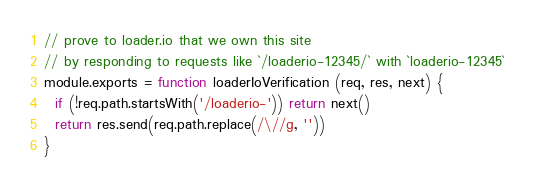<code> <loc_0><loc_0><loc_500><loc_500><_JavaScript_>// prove to loader.io that we own this site
// by responding to requests like `/loaderio-12345/` with `loaderio-12345`
module.exports = function loaderIoVerification (req, res, next) {
  if (!req.path.startsWith('/loaderio-')) return next()
  return res.send(req.path.replace(/\//g, ''))
}
</code> 